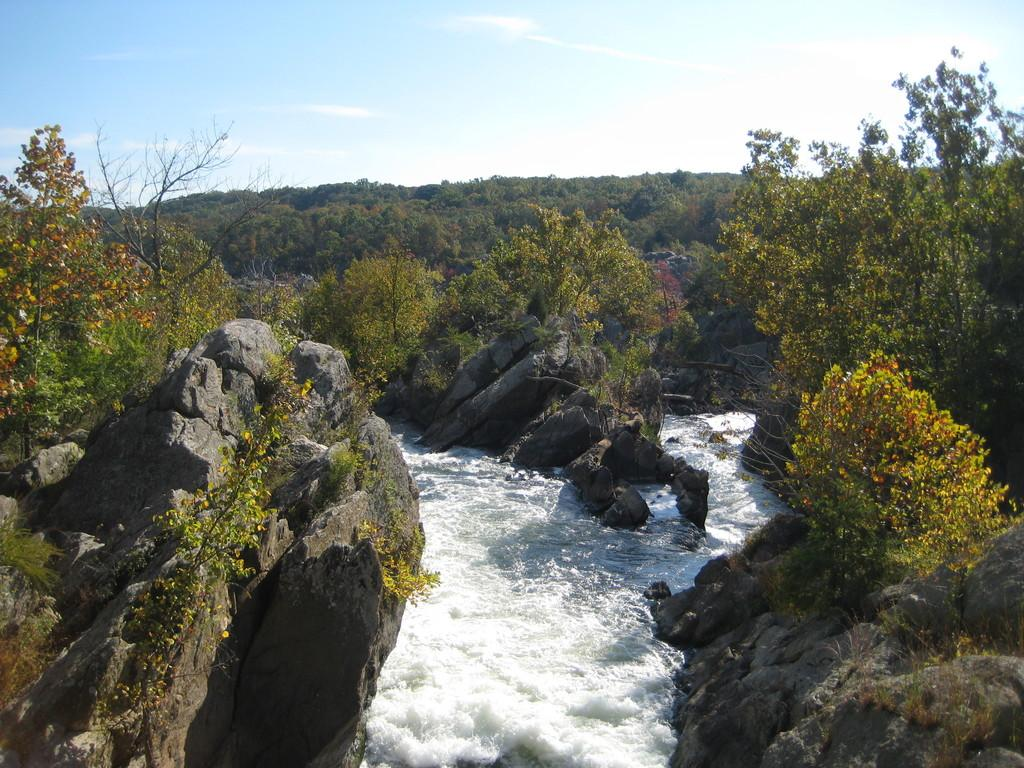What type of body of water is present in the image? There is a water lake in the image. What other natural elements can be seen in the image? There are rocks and trees visible in the image. How many fingers can be seen pointing at the lake in the image? There are no fingers visible in the image, as it features a water lake, rocks, and trees. 